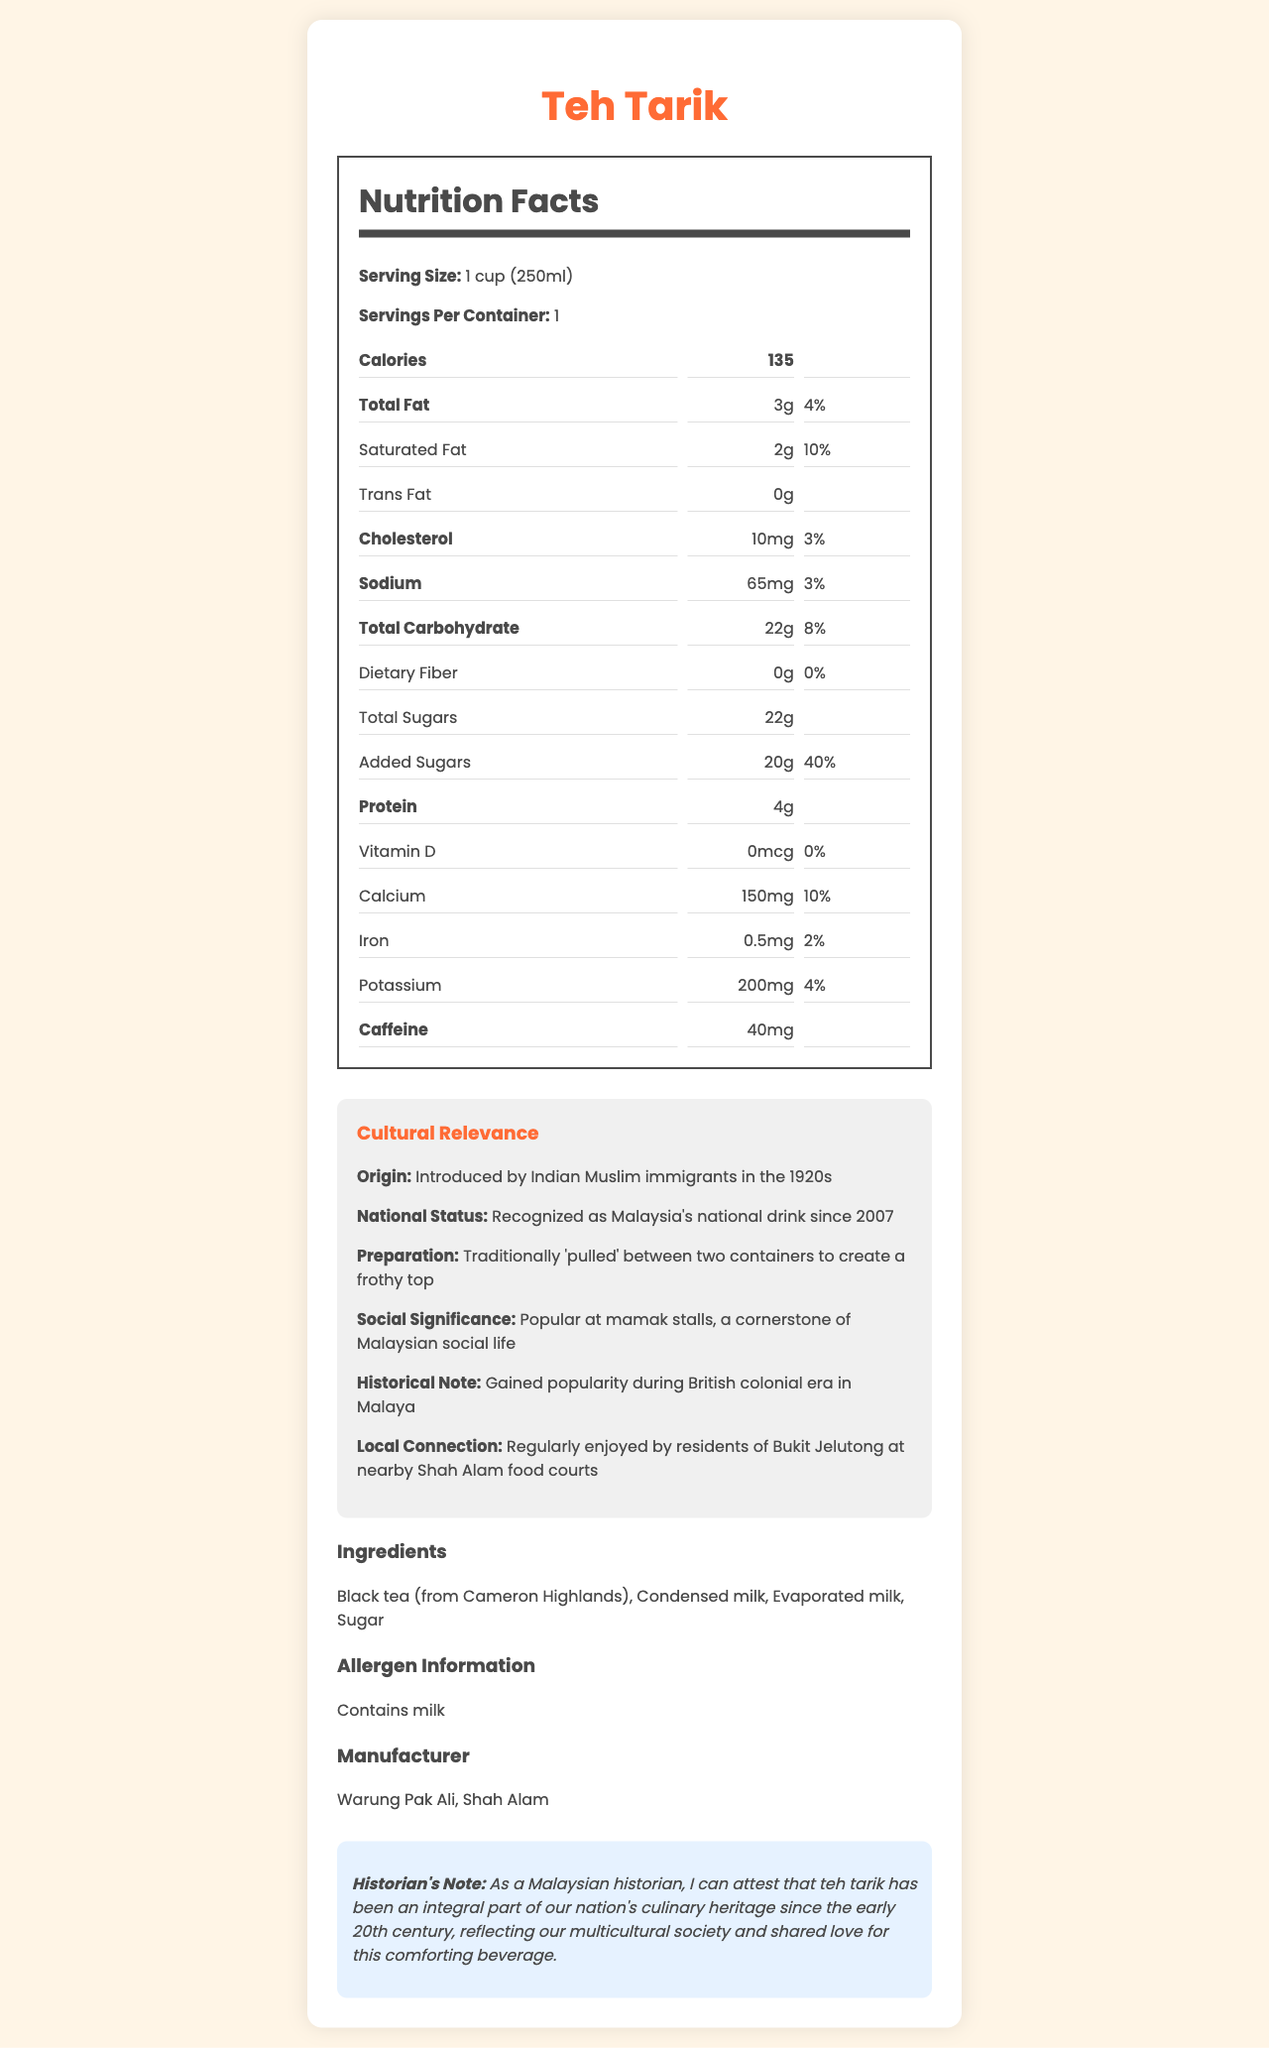what is the calorie count in one serving of teh tarik? The document states that each serving of teh tarik contains 135 calories.
Answer: 135 how much caffeine is in one cup of teh tarik? The document mentions that one cup of teh tarik contains 40mg of caffeine.
Answer: 40mg what percentage of the daily value for calcium does one cup of teh tarik provide? According to the document, one cup of teh tarik provides 10% of the daily value for calcium.
Answer: 10% what ingredient in teh tarik can cause allergies? The document states that teh tarik contains milk, which is listed under allergen information.
Answer: Milk how many grams of protein does one serving of teh tarik contain? The document specifies that one serving of teh tarik contains 4 grams of protein.
Answer: 4g when was teh tarik recognized as Malaysia's national drink? A. 1920 B. 2007 C. 1957 D. 1983 The document states that teh tarik has been recognized as Malaysia's national drink since 2007.
Answer: B. 2007 who manufactured this teh tarik? A. Teh Ais Shop B. Café Malaysia C. Warung Pak Ali D. Teh Tarik Malaysia The document indicates that Warung Pak Ali is the manufacturer.
Answer: C. Warung Pak Ali is there any dietary fiber in teh tarik? The document mentions that teh tarik contains 0g of dietary fiber.
Answer: No summarize the main cultural relevance of teh tarik. The document highlights teh tarik's origins, its significance in Malaysian culture, its traditional preparation method, and its current social role.
Answer: Teh tarik, introduced by Indian Muslim immigrants in the 1920s, is Malaysia's national drink recognized since 2007. It is traditionally prepared by 'pulling' the tea to create a frothy top, and is popular at mamak stalls where it forms a cornerstone of Malaysian social life. It gained popularity during the British colonial era and is regularly enjoyed in places like Bukit Jelutong. how many grams of added sugars are in one serving of teh tarik? The document states that one serving of teh tarik contains 20 grams of added sugars.
Answer: 20g what is the origin of teh tarik? The document mentions that teh tarik was introduced by Indian Muslim immigrants in the 1920s.
Answer: Introduced by Indian Muslim immigrants in the 1920s what is the serving size of teh tarik? The serving size of teh tarik is listed as 1 cup (250ml).
Answer: 1 cup (250ml) how many servings are there per container? The document states there is 1 serving per container of teh tarik.
Answer: 1 how much sodium does one cup of teh tarik contain? According to the document, one cup of teh tarik contains 65mg of sodium.
Answer: 65mg what are the main ingredients of teh tarik? The ingredients listed in the document are black tea (from Cameron Highlands), condensed milk, evaporated milk, and sugar.
Answer: Black tea (from Cameron Highlands), Condensed milk, Evaporated milk, Sugar what is the social significance of teh tarik? The document states that teh tarik is popular at mamak stalls and is an important part of Malaysian social life.
Answer: Popular at mamak stalls, a cornerstone of Malaysian social life what was the daily value percentage of cholesterol in one serving of teh tarik? The document specifies that the cholesterol in one serving of teh tarik is 3% of the daily value.
Answer: 3% where can I find the headquarters of the manufacturer? The document lists the manufacturer as Warung Pak Ali but does not provide information about its headquarters or specific location.
Answer: Cannot be determined 